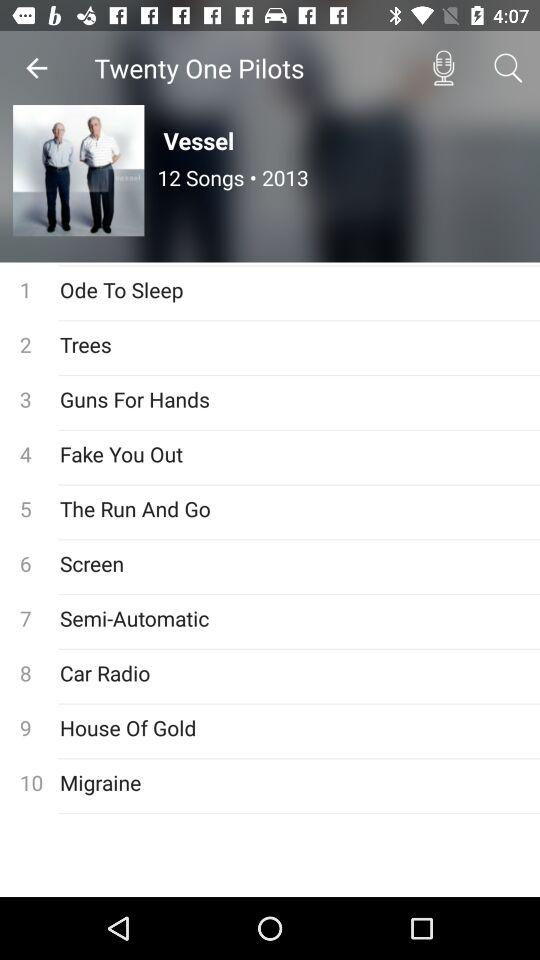In what year was the album released? The album was released in 2013. 